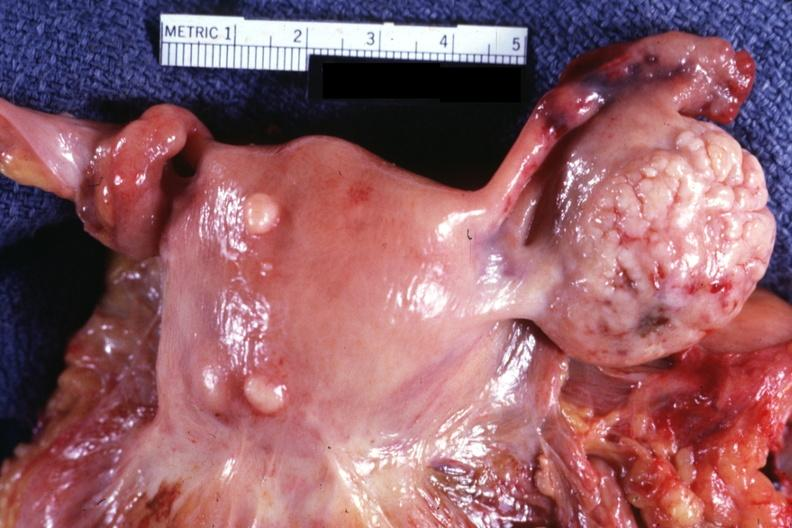what is present?
Answer the question using a single word or phrase. Female reproductive 